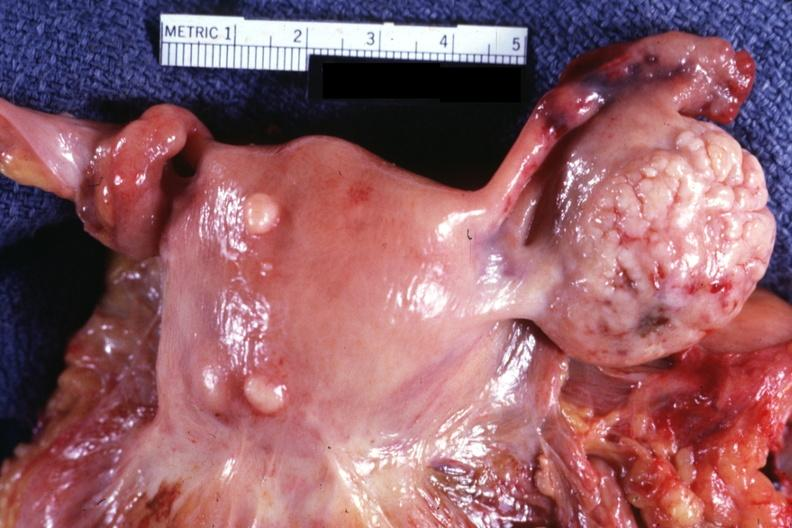what is present?
Answer the question using a single word or phrase. Female reproductive 